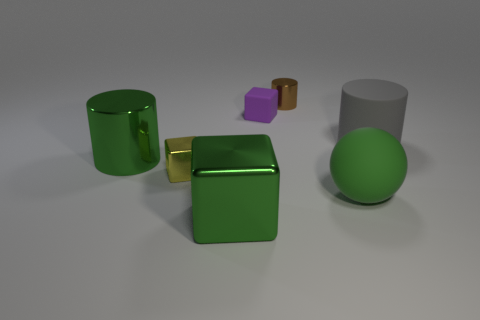How many objects are green matte cubes or small rubber cubes?
Offer a very short reply. 1. Are any big blue metal things visible?
Make the answer very short. No. Are there fewer big rubber objects than green objects?
Give a very brief answer. Yes. Are there any brown cylinders of the same size as the purple matte block?
Offer a very short reply. Yes. There is a small brown thing; is its shape the same as the big rubber object behind the big metal cylinder?
Provide a succinct answer. Yes. What number of cylinders are large gray matte things or yellow objects?
Offer a very short reply. 1. The tiny shiny cylinder is what color?
Your response must be concise. Brown. Is the number of purple matte cubes greater than the number of metallic objects?
Give a very brief answer. No. What number of objects are either big cylinders that are right of the brown metallic object or small brown things?
Provide a succinct answer. 2. Is the brown object made of the same material as the yellow cube?
Offer a terse response. Yes. 